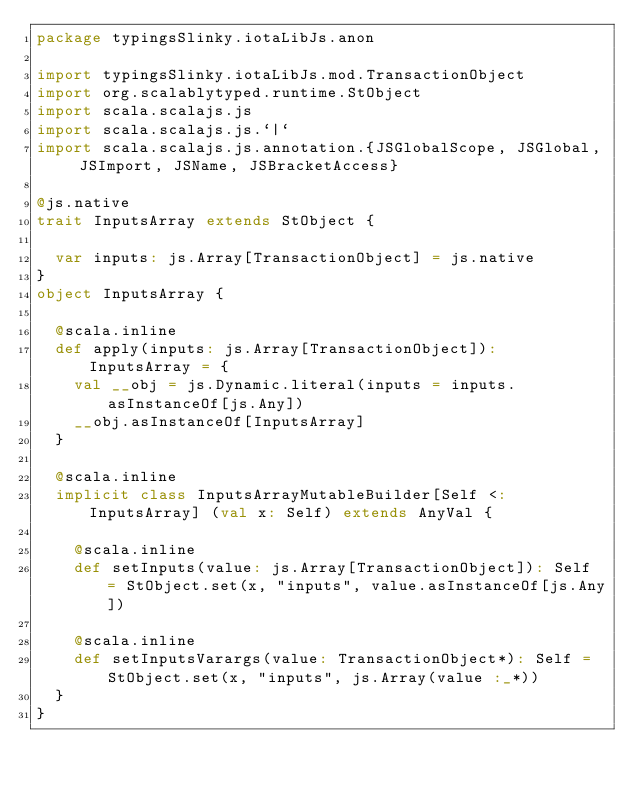<code> <loc_0><loc_0><loc_500><loc_500><_Scala_>package typingsSlinky.iotaLibJs.anon

import typingsSlinky.iotaLibJs.mod.TransactionObject
import org.scalablytyped.runtime.StObject
import scala.scalajs.js
import scala.scalajs.js.`|`
import scala.scalajs.js.annotation.{JSGlobalScope, JSGlobal, JSImport, JSName, JSBracketAccess}

@js.native
trait InputsArray extends StObject {
  
  var inputs: js.Array[TransactionObject] = js.native
}
object InputsArray {
  
  @scala.inline
  def apply(inputs: js.Array[TransactionObject]): InputsArray = {
    val __obj = js.Dynamic.literal(inputs = inputs.asInstanceOf[js.Any])
    __obj.asInstanceOf[InputsArray]
  }
  
  @scala.inline
  implicit class InputsArrayMutableBuilder[Self <: InputsArray] (val x: Self) extends AnyVal {
    
    @scala.inline
    def setInputs(value: js.Array[TransactionObject]): Self = StObject.set(x, "inputs", value.asInstanceOf[js.Any])
    
    @scala.inline
    def setInputsVarargs(value: TransactionObject*): Self = StObject.set(x, "inputs", js.Array(value :_*))
  }
}
</code> 